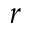Convert formula to latex. <formula><loc_0><loc_0><loc_500><loc_500>r</formula> 